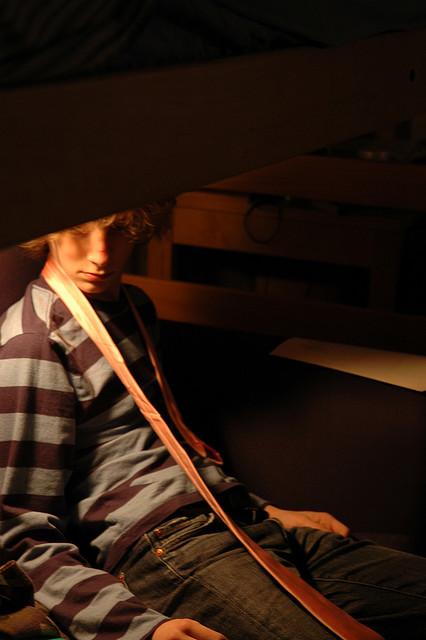What pattern is on boy's shirt?
Concise answer only. Stripes. Is the man in motion?
Keep it brief. No. Is the boy wearing a tie?
Answer briefly. Yes. What is around the boy's neck?
Keep it brief. Tie. 